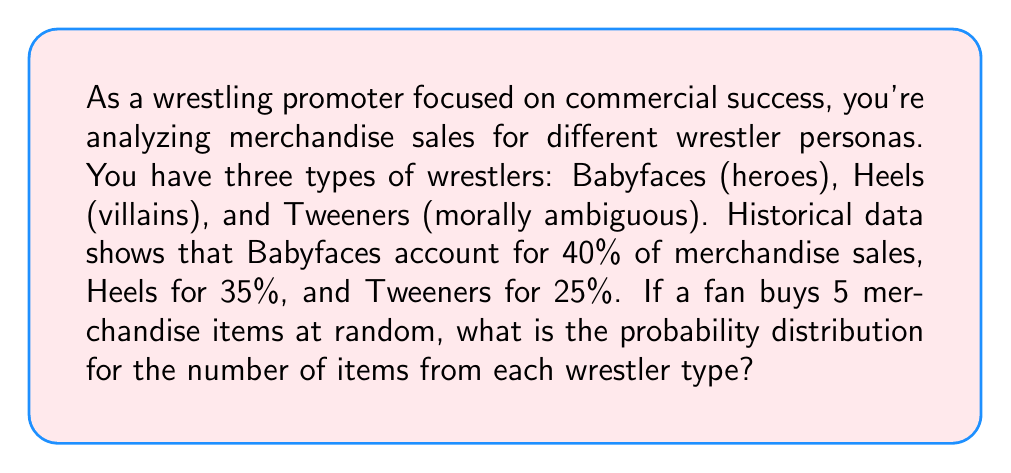Show me your answer to this math problem. This problem can be solved using the multinomial distribution. Let's approach this step-by-step:

1) We have a multinomial distribution with $n=5$ trials and $k=3$ categories (Babyface, Heel, Tweener).

2) The probabilities for each category are:
   $p_1 = 0.40$ (Babyface)
   $p_2 = 0.35$ (Heel)
   $p_3 = 0.25$ (Tweener)

3) The probability mass function for the multinomial distribution is:

   $$P(X_1 = x_1, X_2 = x_2, X_3 = x_3) = \frac{n!}{x_1!x_2!x_3!} p_1^{x_1} p_2^{x_2} p_3^{x_3}$$

   where $x_1 + x_2 + x_3 = n$

4) We need to calculate this for all possible combinations of $(x_1, x_2, x_3)$ where $x_1 + x_2 + x_3 = 5$

5) The possible combinations are:
   (5,0,0), (4,1,0), (4,0,1), (3,2,0), (3,1,1), (3,0,2), (2,3,0), (2,2,1), (2,1,2), (2,0,3),
   (1,4,0), (1,3,1), (1,2,2), (1,1,3), (1,0,4), (0,5,0), (0,4,1), (0,3,2), (0,2,3), (0,1,4), (0,0,5)

6) Let's calculate for (3,1,1) as an example:

   $$P(3,1,1) = \frac{5!}{3!1!1!} 0.40^3 0.35^1 0.25^1 = 10 \times 0.064 \times 0.35 \times 0.25 = 0.056$$

7) Repeating this process for all combinations gives us the complete probability distribution.
Answer: Probability distribution: (5,0,0):0.01024, (4,1,0):0.0448, (4,0,1):0.032, (3,2,0):0.0784, (3,1,1):0.056, (3,0,2):0.02, (2,3,0):0.0686, (2,2,1):0.098, (2,1,2):0.07, (2,0,3):0.0125, (1,4,0):0.03, (1,3,1):0.0857, (1,2,2):0.1225, (1,1,3):0.0875, (1,0,4):0.0078125, (0,5,0):0.00525, (0,4,1):0.015, (0,3,2):0.0428, (0,2,3):0.0609, (0,1,4):0.0434, (0,0,5):0.0009765625 